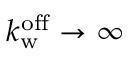Convert formula to latex. <formula><loc_0><loc_0><loc_500><loc_500>k _ { w } ^ { o f f } \rightarrow \infty</formula> 